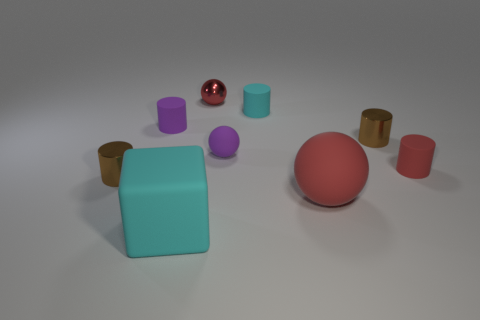How many objects are either small rubber objects on the left side of the big block or purple cylinders? 1 